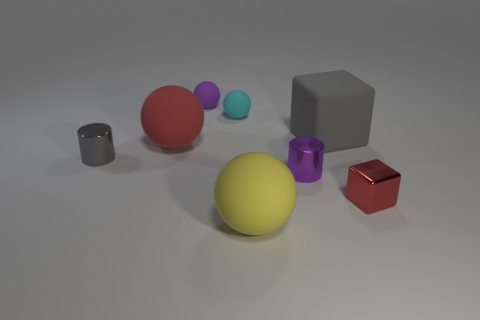Subtract 2 spheres. How many spheres are left? 2 Subtract all purple cylinders. How many cylinders are left? 1 Add 2 large things. How many objects exist? 10 Subtract all cylinders. How many objects are left? 6 Subtract all brown spheres. How many purple cylinders are left? 1 Subtract all tiny red metal objects. Subtract all small matte things. How many objects are left? 5 Add 6 tiny red objects. How many tiny red objects are left? 7 Add 2 red rubber things. How many red rubber things exist? 3 Subtract 1 red cubes. How many objects are left? 7 Subtract all blue cubes. Subtract all red spheres. How many cubes are left? 2 